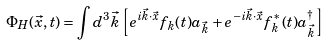Convert formula to latex. <formula><loc_0><loc_0><loc_500><loc_500>\Phi _ { H } ( \vec { x } , t ) = \int d ^ { 3 } \vec { k } \left [ e ^ { i \vec { k } \cdot \vec { x } } f _ { k } ( t ) a _ { \vec { k } } + e ^ { - i \vec { k } \cdot \vec { x } } f ^ { * } _ { k } ( t ) a ^ { \dag } _ { \vec { k } } \right ]</formula> 